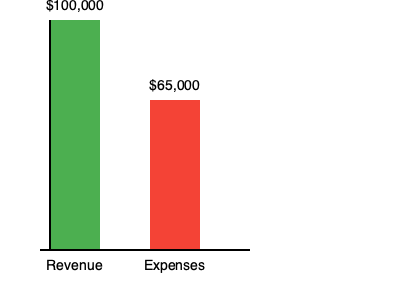As a business owner who values ethical practices, you want to ensure your profit margins are sustainable while maintaining fair prices for your customers. Using the bar graph showing your business's revenue and expenses, calculate the profit margin percentage. How does this align with your commitment to ethical business practices? To calculate the profit margin percentage, we'll follow these steps:

1. Identify the revenue and expenses from the graph:
   Revenue = $100,000
   Expenses = $65,000

2. Calculate the profit:
   Profit = Revenue - Expenses
   $100,000 - $65,000 = $35,000

3. Calculate the profit margin percentage:
   Profit Margin % = (Profit / Revenue) × 100
   ($35,000 / $100,000) × 100 = 35%

The profit margin percentage is 35%.

Ethical considerations:
A 35% profit margin is generally considered healthy for most businesses. It allows for:
- Reinvestment in the business
- Fair wages for employees
- Reasonable prices for customers
- Sustainability and financial stability

However, as an ethically-minded business owner, you might want to consider:
- Are you providing value commensurate with this profit margin?
- Could you lower prices to benefit customers while maintaining sustainability?
- Are you using some of the profits for community benefit or charitable causes?
- Are your expenses optimized without compromising on quality or fair treatment of suppliers and employees?

The goal is to balance profitability with ethical considerations, ensuring the business remains sustainable while adhering to your moral compass.
Answer: 35%; ethically sound if balanced with fair practices and community benefit 